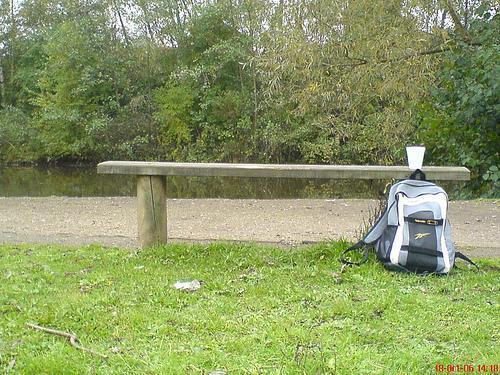How many cups are there?
Give a very brief answer. 1. 